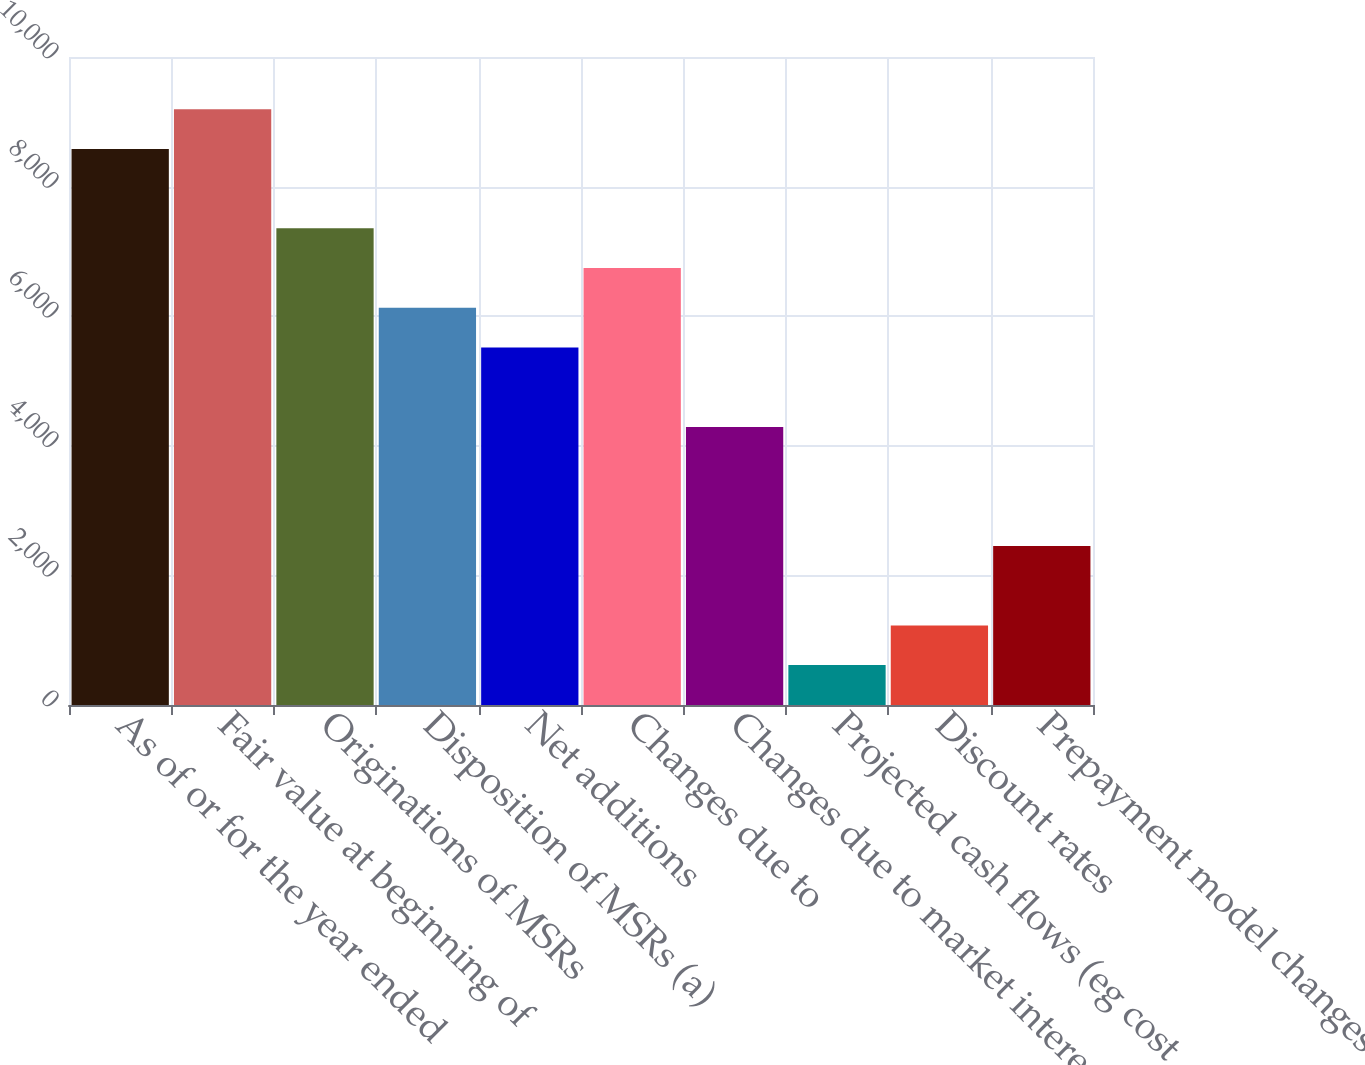<chart> <loc_0><loc_0><loc_500><loc_500><bar_chart><fcel>As of or for the year ended<fcel>Fair value at beginning of<fcel>Originations of MSRs<fcel>Disposition of MSRs (a)<fcel>Net additions<fcel>Changes due to<fcel>Changes due to market interest<fcel>Projected cash flows (eg cost<fcel>Discount rates<fcel>Prepayment model changes and<nl><fcel>8580.8<fcel>9193.5<fcel>7355.4<fcel>6130<fcel>5517.3<fcel>6742.7<fcel>4291.9<fcel>615.7<fcel>1228.4<fcel>2453.8<nl></chart> 